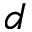Convert formula to latex. <formula><loc_0><loc_0><loc_500><loc_500>d</formula> 